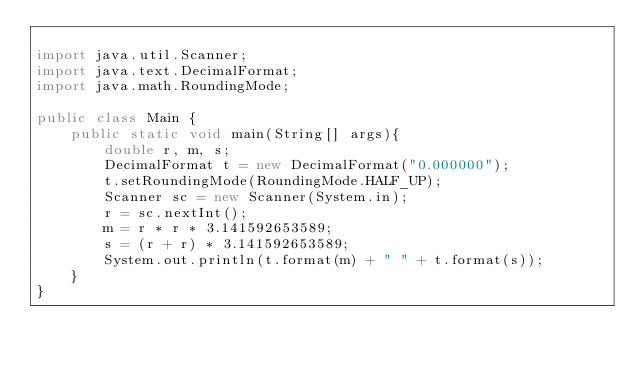Convert code to text. <code><loc_0><loc_0><loc_500><loc_500><_Java_>
import java.util.Scanner;
import java.text.DecimalFormat;
import java.math.RoundingMode;

public class Main {
	public static void main(String[] args){
		double r, m, s;
		DecimalFormat t = new DecimalFormat("0.000000");
		t.setRoundingMode(RoundingMode.HALF_UP);
		Scanner sc = new Scanner(System.in);
		r = sc.nextInt();
		m = r * r * 3.141592653589;
		s = (r + r) * 3.141592653589;
		System.out.println(t.format(m) + " " + t.format(s));
	}
}</code> 